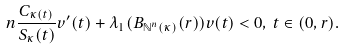Convert formula to latex. <formula><loc_0><loc_0><loc_500><loc_500>n \frac { C _ { \kappa ( t ) } } { S _ { \kappa } ( t ) } v ^ { \prime } ( t ) + \lambda _ { 1 } ( B _ { \mathbb { N } ^ { n } ( \kappa ) } ( r ) ) v ( t ) < 0 , \, t \in ( 0 , r ) .</formula> 